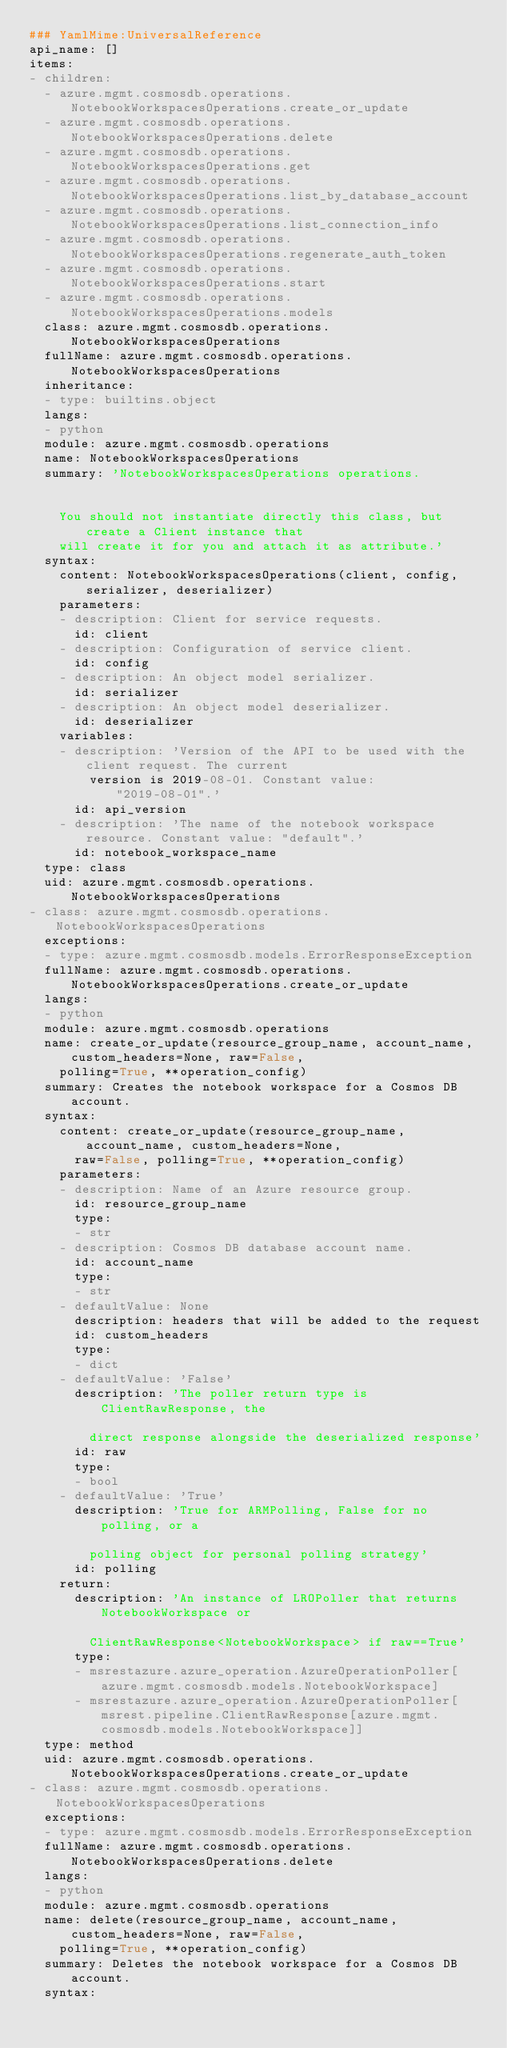<code> <loc_0><loc_0><loc_500><loc_500><_YAML_>### YamlMime:UniversalReference
api_name: []
items:
- children:
  - azure.mgmt.cosmosdb.operations.NotebookWorkspacesOperations.create_or_update
  - azure.mgmt.cosmosdb.operations.NotebookWorkspacesOperations.delete
  - azure.mgmt.cosmosdb.operations.NotebookWorkspacesOperations.get
  - azure.mgmt.cosmosdb.operations.NotebookWorkspacesOperations.list_by_database_account
  - azure.mgmt.cosmosdb.operations.NotebookWorkspacesOperations.list_connection_info
  - azure.mgmt.cosmosdb.operations.NotebookWorkspacesOperations.regenerate_auth_token
  - azure.mgmt.cosmosdb.operations.NotebookWorkspacesOperations.start
  - azure.mgmt.cosmosdb.operations.NotebookWorkspacesOperations.models
  class: azure.mgmt.cosmosdb.operations.NotebookWorkspacesOperations
  fullName: azure.mgmt.cosmosdb.operations.NotebookWorkspacesOperations
  inheritance:
  - type: builtins.object
  langs:
  - python
  module: azure.mgmt.cosmosdb.operations
  name: NotebookWorkspacesOperations
  summary: 'NotebookWorkspacesOperations operations.


    You should not instantiate directly this class, but create a Client instance that
    will create it for you and attach it as attribute.'
  syntax:
    content: NotebookWorkspacesOperations(client, config, serializer, deserializer)
    parameters:
    - description: Client for service requests.
      id: client
    - description: Configuration of service client.
      id: config
    - description: An object model serializer.
      id: serializer
    - description: An object model deserializer.
      id: deserializer
    variables:
    - description: 'Version of the API to be used with the client request. The current
        version is 2019-08-01. Constant value: "2019-08-01".'
      id: api_version
    - description: 'The name of the notebook workspace resource. Constant value: "default".'
      id: notebook_workspace_name
  type: class
  uid: azure.mgmt.cosmosdb.operations.NotebookWorkspacesOperations
- class: azure.mgmt.cosmosdb.operations.NotebookWorkspacesOperations
  exceptions:
  - type: azure.mgmt.cosmosdb.models.ErrorResponseException
  fullName: azure.mgmt.cosmosdb.operations.NotebookWorkspacesOperations.create_or_update
  langs:
  - python
  module: azure.mgmt.cosmosdb.operations
  name: create_or_update(resource_group_name, account_name, custom_headers=None, raw=False,
    polling=True, **operation_config)
  summary: Creates the notebook workspace for a Cosmos DB account.
  syntax:
    content: create_or_update(resource_group_name, account_name, custom_headers=None,
      raw=False, polling=True, **operation_config)
    parameters:
    - description: Name of an Azure resource group.
      id: resource_group_name
      type:
      - str
    - description: Cosmos DB database account name.
      id: account_name
      type:
      - str
    - defaultValue: None
      description: headers that will be added to the request
      id: custom_headers
      type:
      - dict
    - defaultValue: 'False'
      description: 'The poller return type is ClientRawResponse, the

        direct response alongside the deserialized response'
      id: raw
      type:
      - bool
    - defaultValue: 'True'
      description: 'True for ARMPolling, False for no polling, or a

        polling object for personal polling strategy'
      id: polling
    return:
      description: 'An instance of LROPoller that returns NotebookWorkspace or

        ClientRawResponse<NotebookWorkspace> if raw==True'
      type:
      - msrestazure.azure_operation.AzureOperationPoller[azure.mgmt.cosmosdb.models.NotebookWorkspace]
      - msrestazure.azure_operation.AzureOperationPoller[msrest.pipeline.ClientRawResponse[azure.mgmt.cosmosdb.models.NotebookWorkspace]]
  type: method
  uid: azure.mgmt.cosmosdb.operations.NotebookWorkspacesOperations.create_or_update
- class: azure.mgmt.cosmosdb.operations.NotebookWorkspacesOperations
  exceptions:
  - type: azure.mgmt.cosmosdb.models.ErrorResponseException
  fullName: azure.mgmt.cosmosdb.operations.NotebookWorkspacesOperations.delete
  langs:
  - python
  module: azure.mgmt.cosmosdb.operations
  name: delete(resource_group_name, account_name, custom_headers=None, raw=False,
    polling=True, **operation_config)
  summary: Deletes the notebook workspace for a Cosmos DB account.
  syntax:</code> 